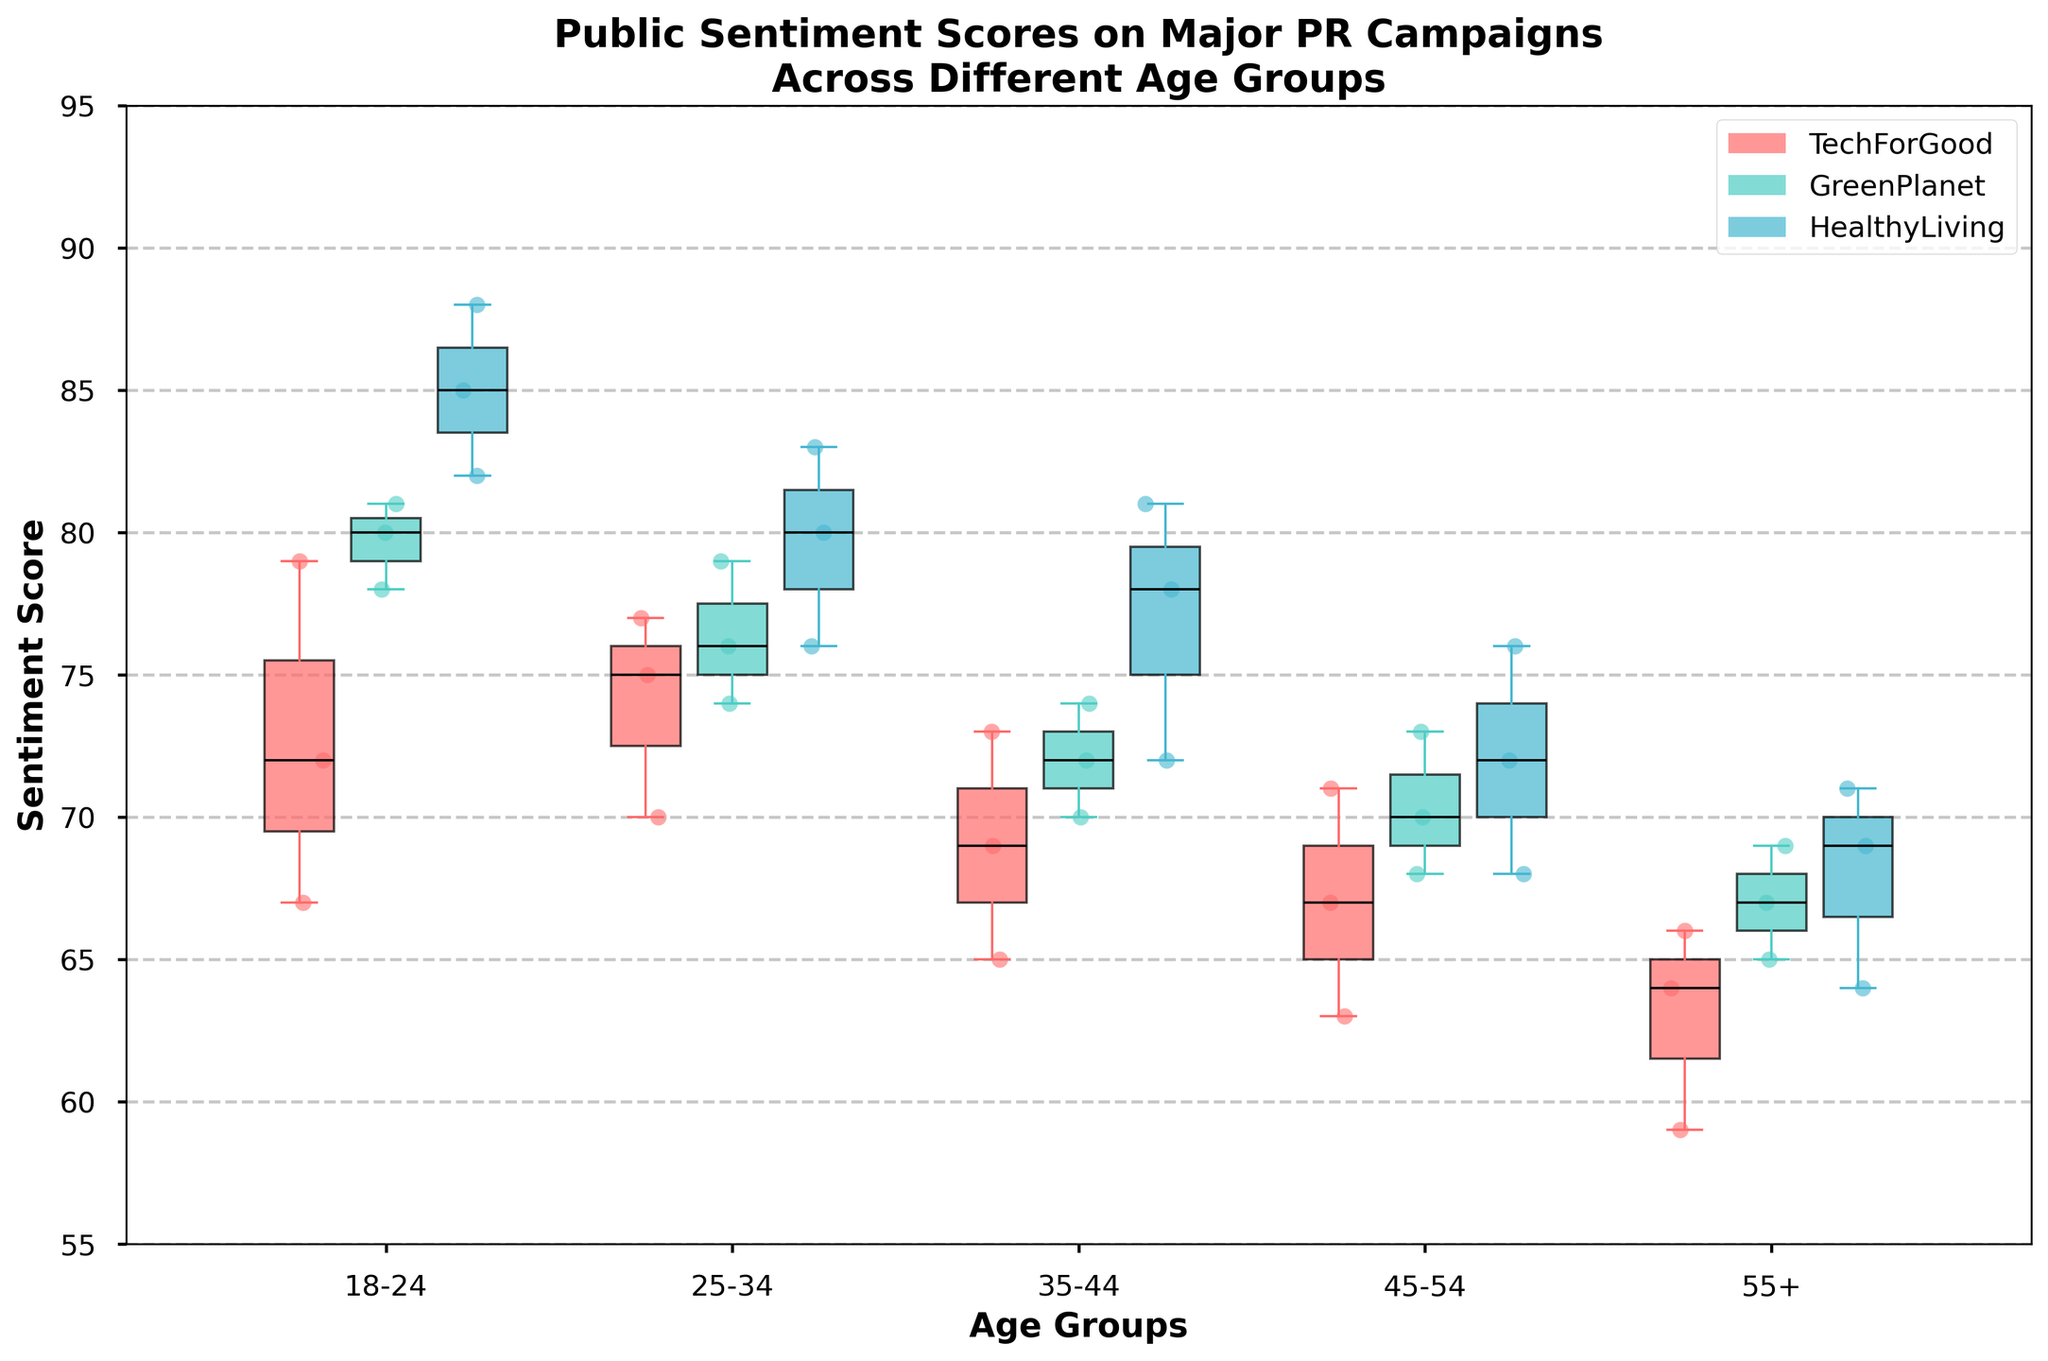What is the title of the figure? The title of the figure can be found at the top of the chart, in a bold and larger font.
Answer: Public Sentiment Scores on Major PR Campaigns Across Different Age Groups What are the age groups listed on the x-axis? The age groups are represented as distinct labels on the x-axis of the plot. These labels are '18-24', '25-34', '35-44', '45-54', '55+'.
Answer: 18-24, 25-34, 35-44, 45-54, 55+ Which campaign has the highest median sentiment score in the 35-44 age group? Locate the median sentiment score for all campaigns within the 35-44 age group. Identify the campaign with the highest median score by comparing the black lines within the colored box plots.
Answer: HealthyLiving For the TechForGood campaign, which age group shows the lowest median sentiment score? Examine the box plot for each age group under the TechForGood campaign. The lowest median score can be observed as the lowest black line among these groups.
Answer: 55+ Are there any outliers in the sentiment scores for the GreenPlanet campaign in the 25-34 age group? Outliers are typically represented as individual scatter points that lie outside the whiskers of the box plots. Check the GreenPlanet campaign box plot for the 25-34 age group for any such points.
Answer: No Which age group has the greatest range of sentiment scores for the HealthyLiving campaign? The range is the difference between the maximum and minimum values in a box plot. Identify the HealthyLiving campaign and compare the whisker span for each age group. The age group with the largest span is the answer.
Answer: 18-24 Which campaign shows the most consistent sentiment scores among the 45-54 age group? Consistency can be determined by the size of the box in a box plot. The smaller the box, the more consistent the sentiment scores. Look for the smallest box plot in the 45-54 age group across all campaigns.
Answer: TechForGood How does the median sentiment score of the GreenPlanet campaign for the 55+ age group compare to the TechForGood campaign for the same age group? Identify the median score for both campaigns in the 55+ age group by locating the black lines within their respective boxes and compare them.
Answer: Higher What is the average sentiment score for the HealthyLiving campaign in the 25-34 age group? (Hint: Calculate the average of the scatter points) To compute the average, add up all the sentiment scores for the HealthyLiving campaign within the 25-34 age group, then divide by the number of scores. So, (76 + 80 + 83) / 3 = 79.67.
Answer: 79.67 Is there any age group where the TechForGood and GreenPlanet campaigns have the same median sentiment score? Compare the median sentiment scores (black lines within the boxes) for each age group between the TechForGood and GreenPlanet campaigns to check for equality.
Answer: No 